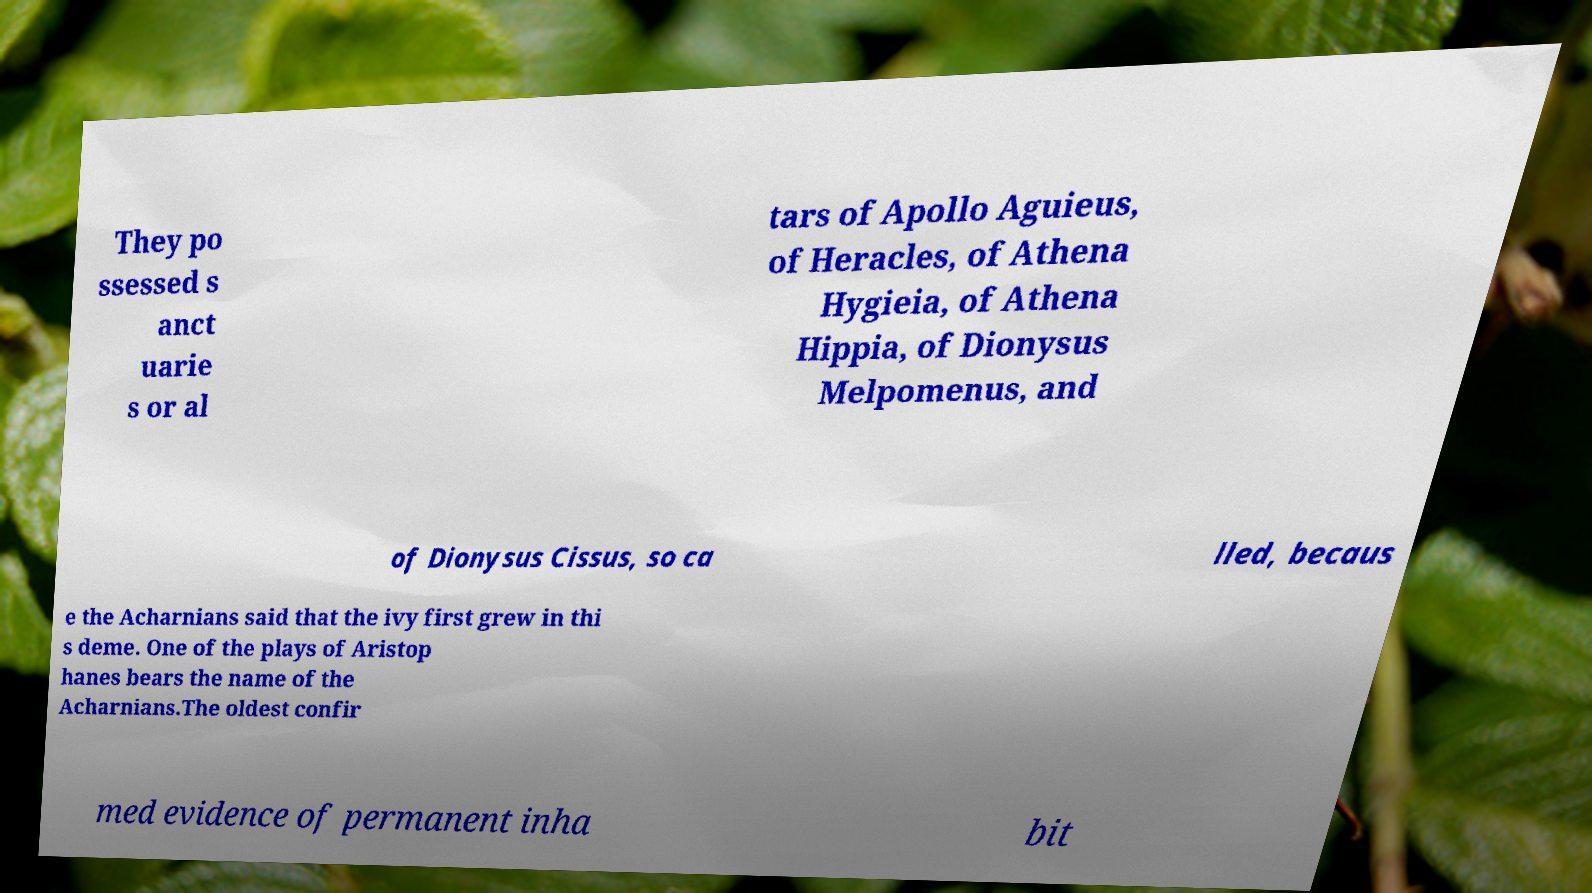Could you assist in decoding the text presented in this image and type it out clearly? They po ssessed s anct uarie s or al tars of Apollo Aguieus, of Heracles, of Athena Hygieia, of Athena Hippia, of Dionysus Melpomenus, and of Dionysus Cissus, so ca lled, becaus e the Acharnians said that the ivy first grew in thi s deme. One of the plays of Aristop hanes bears the name of the Acharnians.The oldest confir med evidence of permanent inha bit 